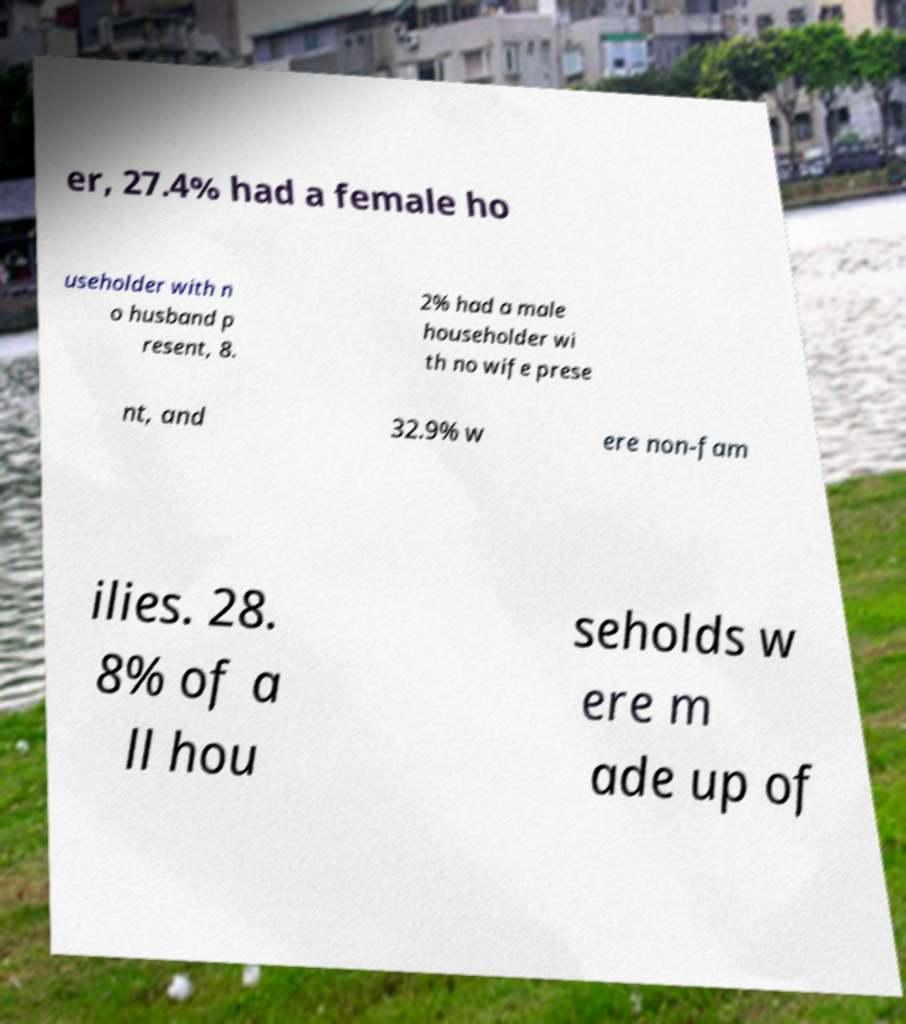Could you extract and type out the text from this image? er, 27.4% had a female ho useholder with n o husband p resent, 8. 2% had a male householder wi th no wife prese nt, and 32.9% w ere non-fam ilies. 28. 8% of a ll hou seholds w ere m ade up of 